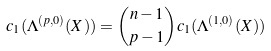<formula> <loc_0><loc_0><loc_500><loc_500>c _ { 1 } ( \Lambda ^ { ( p , 0 ) } ( X ) ) = \binom { n - 1 } { p - 1 } c _ { 1 } ( \Lambda ^ { ( 1 , 0 ) } ( X ) )</formula> 